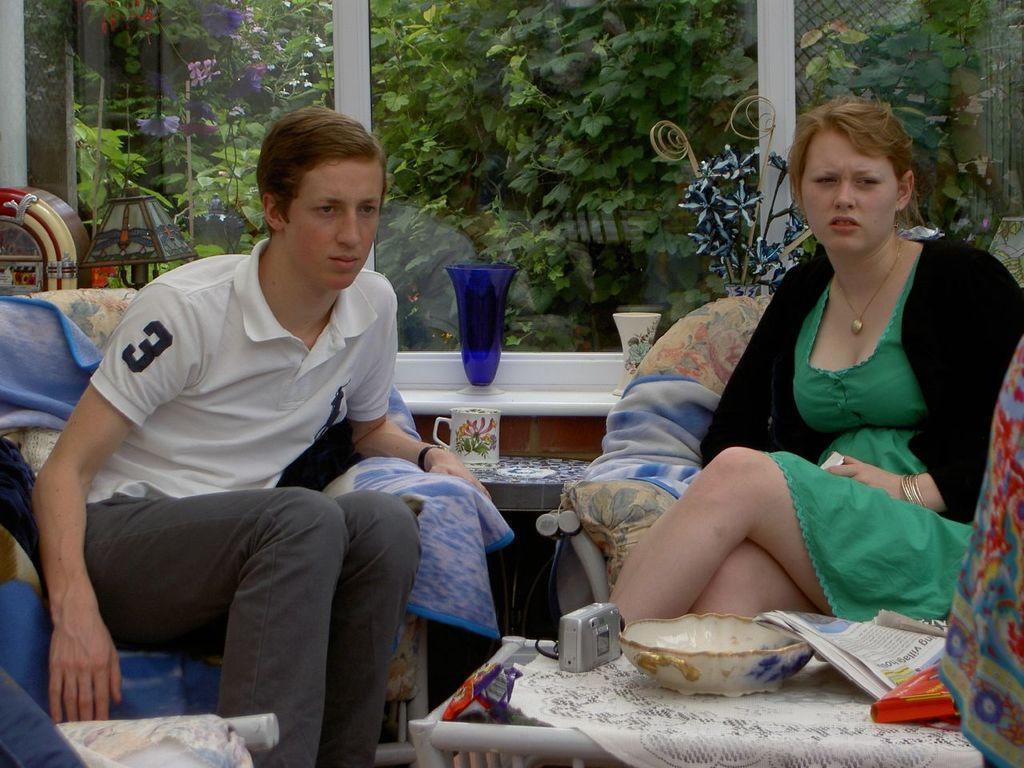In one or two sentences, can you explain what this image depicts? In the picture I can see people are sitting in the chairs, in front one table in which we can see some objects, behind there is a glass window and some potted plants. 